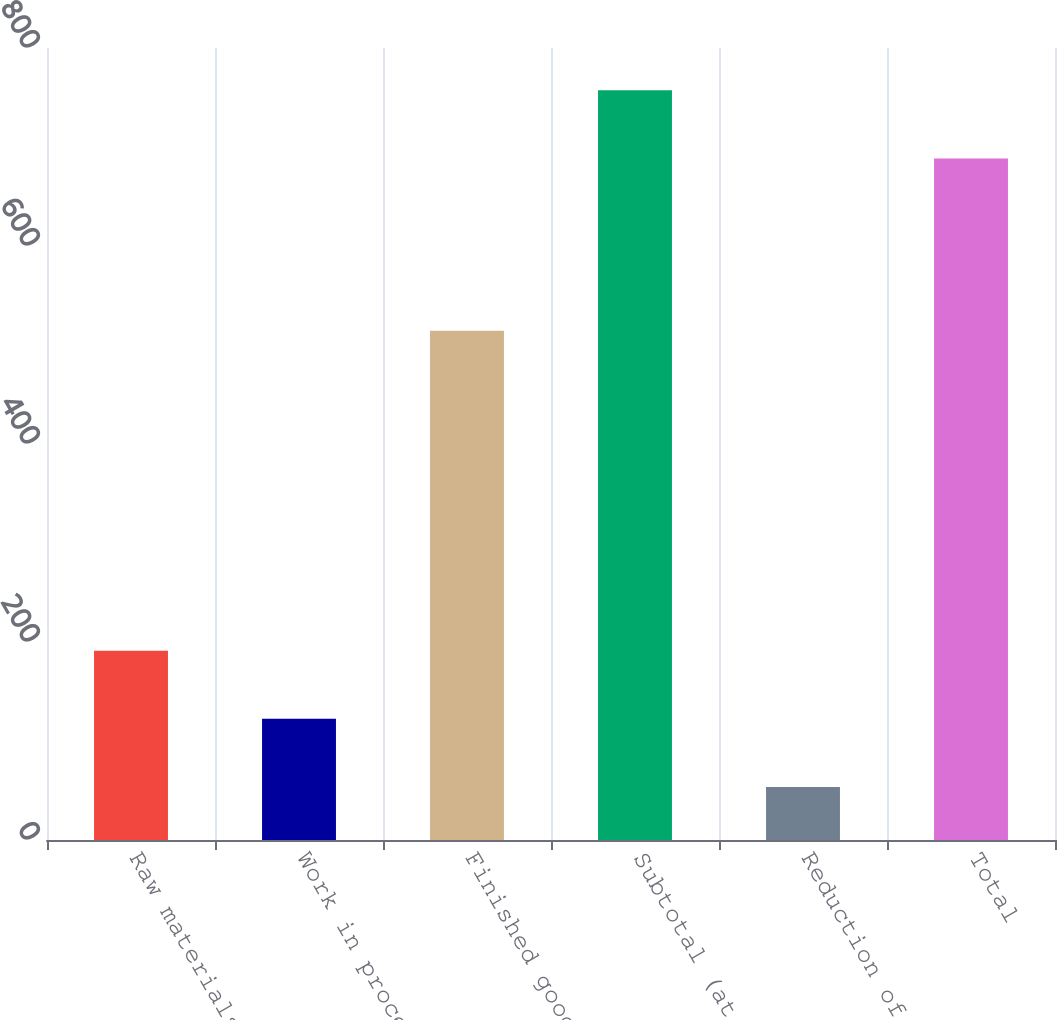Convert chart to OTSL. <chart><loc_0><loc_0><loc_500><loc_500><bar_chart><fcel>Raw materials<fcel>Work in process<fcel>Finished goods<fcel>Subtotal (at FIFO)<fcel>Reduction of certain<fcel>Total<nl><fcel>191.28<fcel>122.44<fcel>514.5<fcel>757.24<fcel>53.6<fcel>688.4<nl></chart> 